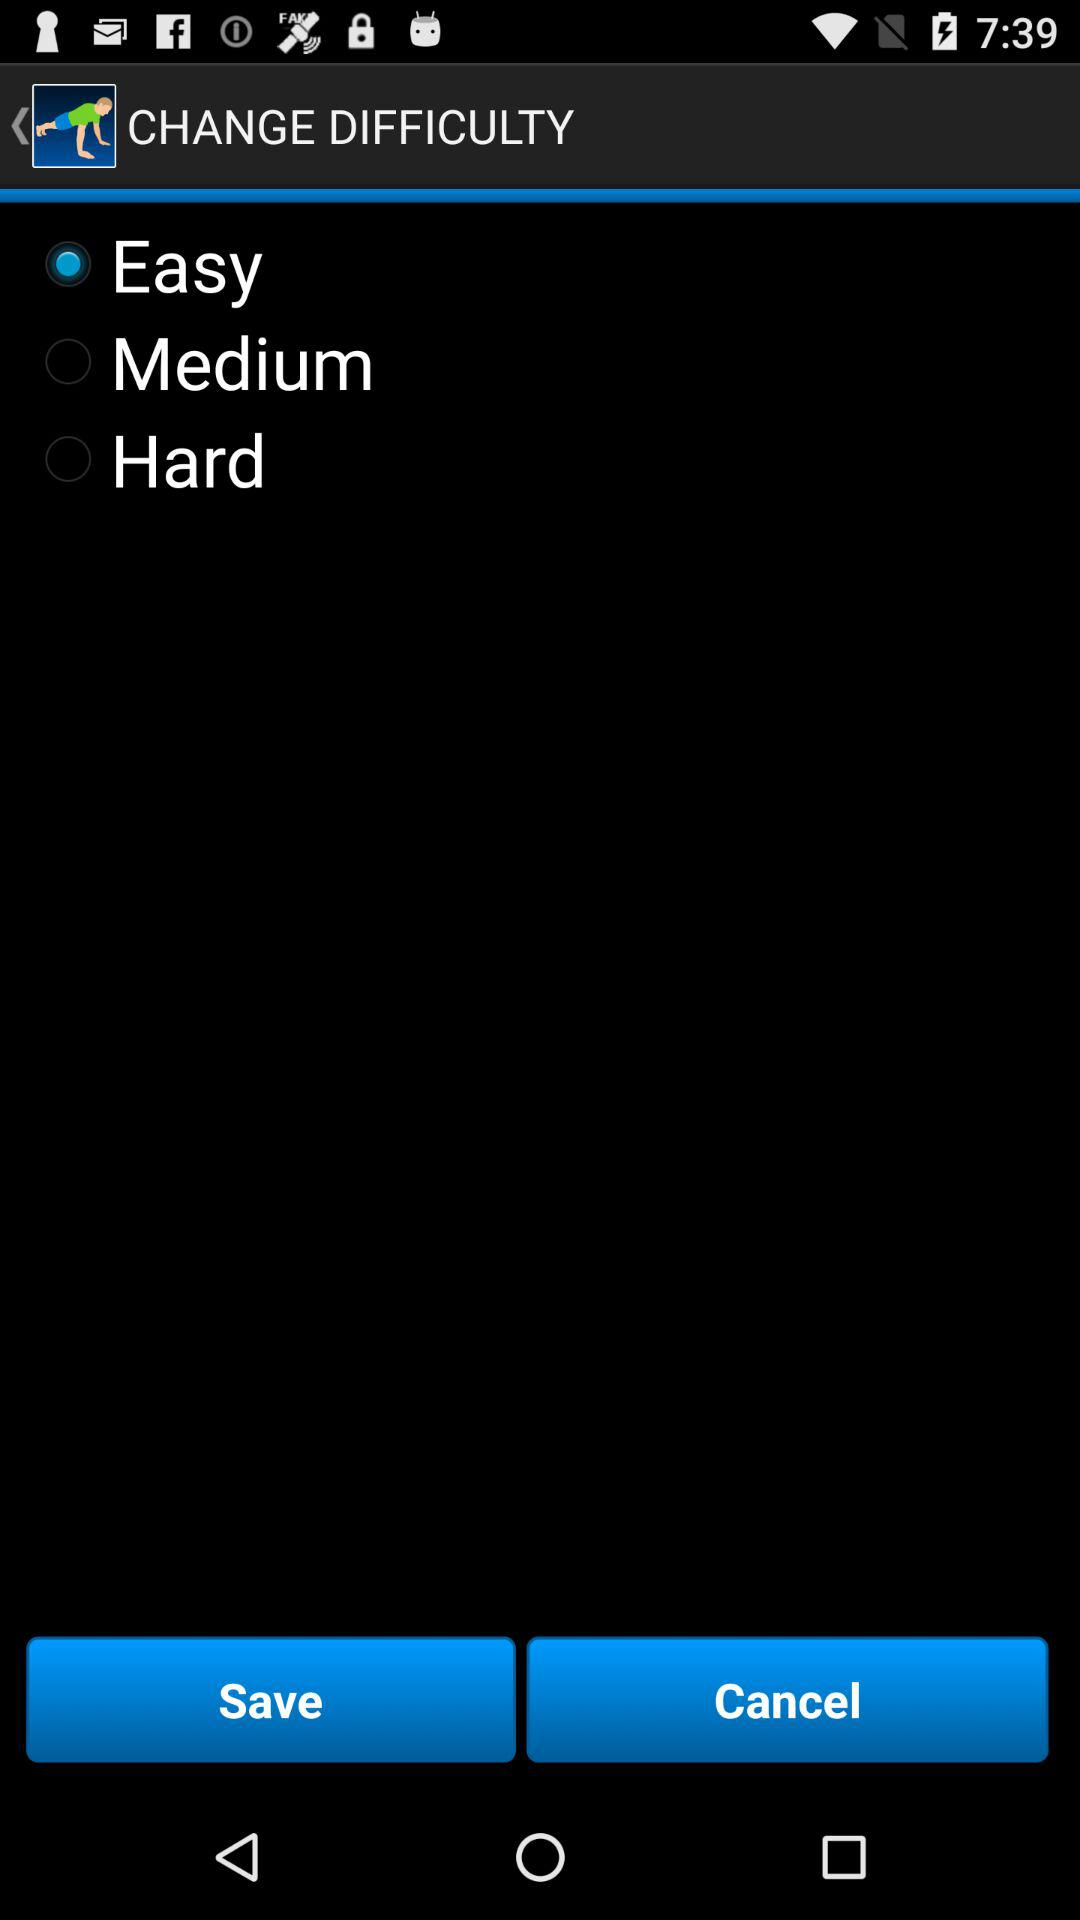What are the levels of difficulty? The levels of difficulty are "Easy", "Medium" and "Hard". 